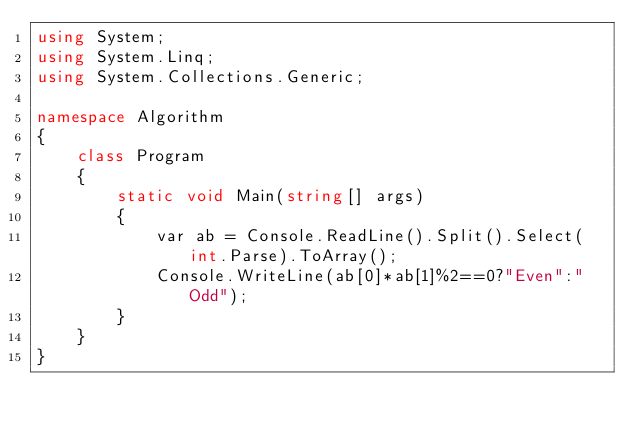<code> <loc_0><loc_0><loc_500><loc_500><_C#_>using System;
using System.Linq;
using System.Collections.Generic;

namespace Algorithm
{
    class Program
    {
        static void Main(string[] args)
        {
            var ab = Console.ReadLine().Split().Select(int.Parse).ToArray();
            Console.WriteLine(ab[0]*ab[1]%2==0?"Even":"Odd");
        }
    }
}
</code> 